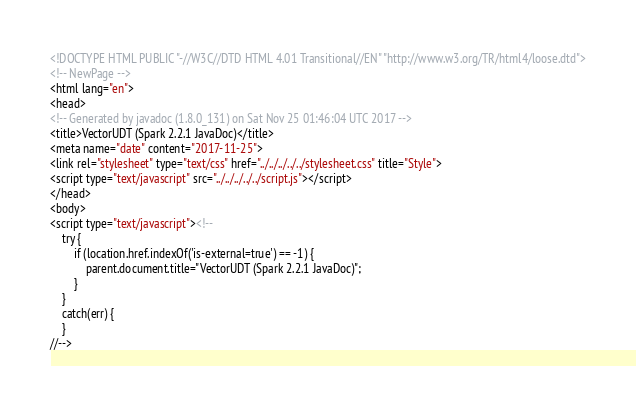Convert code to text. <code><loc_0><loc_0><loc_500><loc_500><_HTML_><!DOCTYPE HTML PUBLIC "-//W3C//DTD HTML 4.01 Transitional//EN" "http://www.w3.org/TR/html4/loose.dtd">
<!-- NewPage -->
<html lang="en">
<head>
<!-- Generated by javadoc (1.8.0_131) on Sat Nov 25 01:46:04 UTC 2017 -->
<title>VectorUDT (Spark 2.2.1 JavaDoc)</title>
<meta name="date" content="2017-11-25">
<link rel="stylesheet" type="text/css" href="../../../../../stylesheet.css" title="Style">
<script type="text/javascript" src="../../../../../script.js"></script>
</head>
<body>
<script type="text/javascript"><!--
    try {
        if (location.href.indexOf('is-external=true') == -1) {
            parent.document.title="VectorUDT (Spark 2.2.1 JavaDoc)";
        }
    }
    catch(err) {
    }
//--></code> 